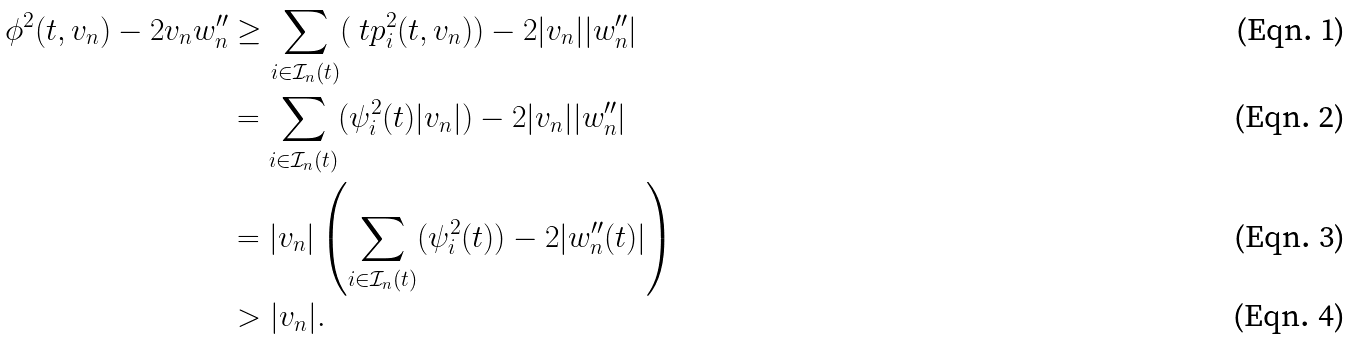<formula> <loc_0><loc_0><loc_500><loc_500>\phi ^ { 2 } ( t , v _ { n } ) - 2 v _ { n } w _ { n } ^ { \prime \prime } & \geq \sum _ { i \in \mathcal { I } _ { n } ( t ) } ( \ t p _ { i } ^ { 2 } ( t , v _ { n } ) ) - 2 | v _ { n } | | w _ { n } ^ { \prime \prime } | \\ & = \sum _ { i \in \mathcal { I } _ { n } ( t ) } ( \psi _ { i } ^ { 2 } ( t ) | v _ { n } | ) - 2 | v _ { n } | | w _ { n } ^ { \prime \prime } | \\ & = | v _ { n } | \left ( \sum _ { i \in \mathcal { I } _ { n } ( t ) } ( \psi _ { i } ^ { 2 } ( t ) ) - 2 | w _ { n } ^ { \prime \prime } ( t ) | \right ) \\ & > | v _ { n } | .</formula> 